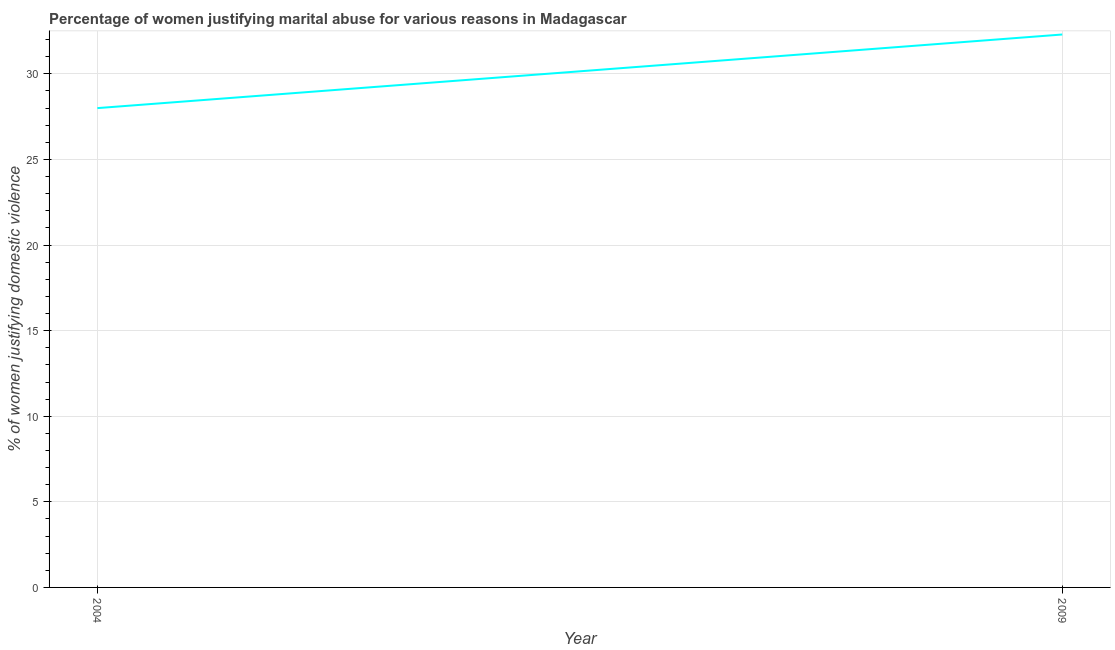Across all years, what is the maximum percentage of women justifying marital abuse?
Offer a very short reply. 32.3. In which year was the percentage of women justifying marital abuse minimum?
Provide a short and direct response. 2004. What is the sum of the percentage of women justifying marital abuse?
Provide a short and direct response. 60.3. What is the difference between the percentage of women justifying marital abuse in 2004 and 2009?
Keep it short and to the point. -4.3. What is the average percentage of women justifying marital abuse per year?
Offer a very short reply. 30.15. What is the median percentage of women justifying marital abuse?
Offer a terse response. 30.15. What is the ratio of the percentage of women justifying marital abuse in 2004 to that in 2009?
Give a very brief answer. 0.87. In how many years, is the percentage of women justifying marital abuse greater than the average percentage of women justifying marital abuse taken over all years?
Your answer should be very brief. 1. Does the percentage of women justifying marital abuse monotonically increase over the years?
Your answer should be compact. Yes. How many lines are there?
Your answer should be very brief. 1. How many years are there in the graph?
Your answer should be very brief. 2. Are the values on the major ticks of Y-axis written in scientific E-notation?
Your answer should be compact. No. Does the graph contain any zero values?
Make the answer very short. No. Does the graph contain grids?
Offer a terse response. Yes. What is the title of the graph?
Offer a terse response. Percentage of women justifying marital abuse for various reasons in Madagascar. What is the label or title of the X-axis?
Provide a succinct answer. Year. What is the label or title of the Y-axis?
Offer a very short reply. % of women justifying domestic violence. What is the % of women justifying domestic violence of 2009?
Provide a short and direct response. 32.3. What is the difference between the % of women justifying domestic violence in 2004 and 2009?
Provide a succinct answer. -4.3. What is the ratio of the % of women justifying domestic violence in 2004 to that in 2009?
Your response must be concise. 0.87. 